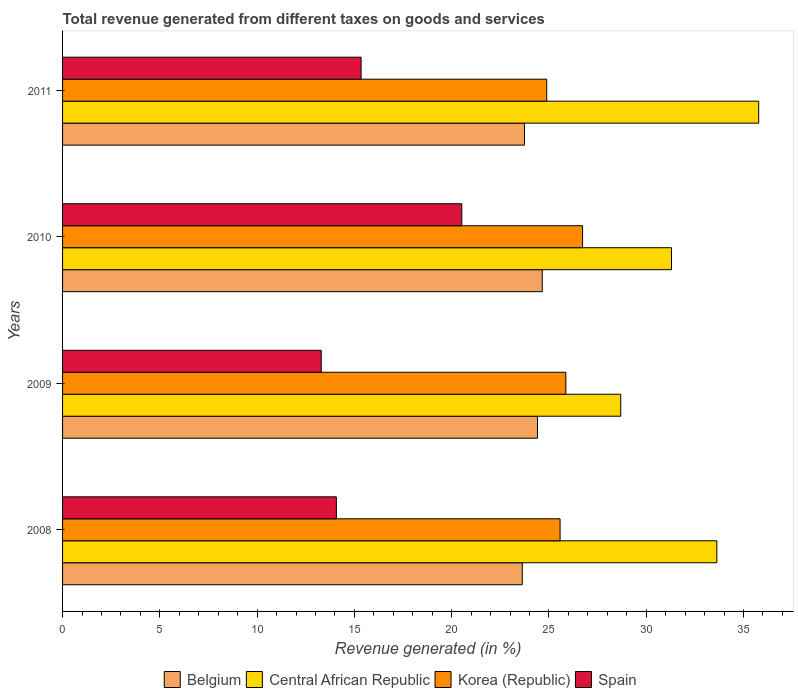How many different coloured bars are there?
Your response must be concise. 4. How many bars are there on the 3rd tick from the top?
Keep it short and to the point. 4. What is the label of the 3rd group of bars from the top?
Provide a short and direct response. 2009. What is the total revenue generated in Spain in 2009?
Offer a very short reply. 13.3. Across all years, what is the maximum total revenue generated in Belgium?
Your response must be concise. 24.65. Across all years, what is the minimum total revenue generated in Belgium?
Offer a very short reply. 23.63. In which year was the total revenue generated in Spain maximum?
Ensure brevity in your answer.  2010. In which year was the total revenue generated in Korea (Republic) minimum?
Provide a short and direct response. 2011. What is the total total revenue generated in Korea (Republic) in the graph?
Make the answer very short. 103.05. What is the difference between the total revenue generated in Central African Republic in 2008 and that in 2009?
Offer a terse response. 4.94. What is the difference between the total revenue generated in Korea (Republic) in 2010 and the total revenue generated in Central African Republic in 2011?
Keep it short and to the point. -9.05. What is the average total revenue generated in Belgium per year?
Offer a very short reply. 24.11. In the year 2009, what is the difference between the total revenue generated in Central African Republic and total revenue generated in Korea (Republic)?
Your answer should be compact. 2.82. What is the ratio of the total revenue generated in Spain in 2009 to that in 2011?
Your response must be concise. 0.87. Is the difference between the total revenue generated in Central African Republic in 2008 and 2009 greater than the difference between the total revenue generated in Korea (Republic) in 2008 and 2009?
Offer a terse response. Yes. What is the difference between the highest and the second highest total revenue generated in Spain?
Your answer should be very brief. 5.18. What is the difference between the highest and the lowest total revenue generated in Spain?
Offer a very short reply. 7.22. Is the sum of the total revenue generated in Central African Republic in 2008 and 2010 greater than the maximum total revenue generated in Belgium across all years?
Offer a terse response. Yes. What does the 3rd bar from the top in 2009 represents?
Offer a terse response. Central African Republic. What does the 2nd bar from the bottom in 2009 represents?
Give a very brief answer. Central African Republic. How many bars are there?
Your response must be concise. 16. Are all the bars in the graph horizontal?
Make the answer very short. Yes. What is the difference between two consecutive major ticks on the X-axis?
Your answer should be very brief. 5. Are the values on the major ticks of X-axis written in scientific E-notation?
Keep it short and to the point. No. Does the graph contain grids?
Offer a very short reply. No. Where does the legend appear in the graph?
Provide a short and direct response. Bottom center. How many legend labels are there?
Ensure brevity in your answer.  4. How are the legend labels stacked?
Provide a short and direct response. Horizontal. What is the title of the graph?
Your response must be concise. Total revenue generated from different taxes on goods and services. Does "Europe(all income levels)" appear as one of the legend labels in the graph?
Your answer should be very brief. No. What is the label or title of the X-axis?
Give a very brief answer. Revenue generated (in %). What is the label or title of the Y-axis?
Provide a short and direct response. Years. What is the Revenue generated (in %) in Belgium in 2008?
Provide a succinct answer. 23.63. What is the Revenue generated (in %) in Central African Republic in 2008?
Your answer should be very brief. 33.63. What is the Revenue generated (in %) in Korea (Republic) in 2008?
Offer a very short reply. 25.57. What is the Revenue generated (in %) of Spain in 2008?
Ensure brevity in your answer.  14.07. What is the Revenue generated (in %) of Belgium in 2009?
Your response must be concise. 24.41. What is the Revenue generated (in %) in Central African Republic in 2009?
Make the answer very short. 28.69. What is the Revenue generated (in %) of Korea (Republic) in 2009?
Give a very brief answer. 25.87. What is the Revenue generated (in %) in Spain in 2009?
Give a very brief answer. 13.3. What is the Revenue generated (in %) of Belgium in 2010?
Your answer should be compact. 24.65. What is the Revenue generated (in %) in Central African Republic in 2010?
Provide a short and direct response. 31.3. What is the Revenue generated (in %) in Korea (Republic) in 2010?
Your answer should be very brief. 26.73. What is the Revenue generated (in %) of Spain in 2010?
Ensure brevity in your answer.  20.52. What is the Revenue generated (in %) of Belgium in 2011?
Your answer should be compact. 23.74. What is the Revenue generated (in %) of Central African Republic in 2011?
Your response must be concise. 35.78. What is the Revenue generated (in %) in Korea (Republic) in 2011?
Provide a short and direct response. 24.88. What is the Revenue generated (in %) in Spain in 2011?
Provide a short and direct response. 15.34. Across all years, what is the maximum Revenue generated (in %) in Belgium?
Give a very brief answer. 24.65. Across all years, what is the maximum Revenue generated (in %) of Central African Republic?
Offer a very short reply. 35.78. Across all years, what is the maximum Revenue generated (in %) in Korea (Republic)?
Ensure brevity in your answer.  26.73. Across all years, what is the maximum Revenue generated (in %) in Spain?
Offer a terse response. 20.52. Across all years, what is the minimum Revenue generated (in %) in Belgium?
Your answer should be very brief. 23.63. Across all years, what is the minimum Revenue generated (in %) of Central African Republic?
Your answer should be very brief. 28.69. Across all years, what is the minimum Revenue generated (in %) in Korea (Republic)?
Your response must be concise. 24.88. Across all years, what is the minimum Revenue generated (in %) in Spain?
Offer a very short reply. 13.3. What is the total Revenue generated (in %) of Belgium in the graph?
Your response must be concise. 96.44. What is the total Revenue generated (in %) of Central African Republic in the graph?
Keep it short and to the point. 129.39. What is the total Revenue generated (in %) in Korea (Republic) in the graph?
Provide a succinct answer. 103.05. What is the total Revenue generated (in %) in Spain in the graph?
Your answer should be compact. 63.23. What is the difference between the Revenue generated (in %) in Belgium in 2008 and that in 2009?
Provide a succinct answer. -0.78. What is the difference between the Revenue generated (in %) in Central African Republic in 2008 and that in 2009?
Give a very brief answer. 4.94. What is the difference between the Revenue generated (in %) in Korea (Republic) in 2008 and that in 2009?
Ensure brevity in your answer.  -0.3. What is the difference between the Revenue generated (in %) of Spain in 2008 and that in 2009?
Offer a very short reply. 0.78. What is the difference between the Revenue generated (in %) of Belgium in 2008 and that in 2010?
Provide a short and direct response. -1.03. What is the difference between the Revenue generated (in %) in Central African Republic in 2008 and that in 2010?
Your response must be concise. 2.33. What is the difference between the Revenue generated (in %) in Korea (Republic) in 2008 and that in 2010?
Your response must be concise. -1.16. What is the difference between the Revenue generated (in %) in Spain in 2008 and that in 2010?
Offer a very short reply. -6.45. What is the difference between the Revenue generated (in %) of Belgium in 2008 and that in 2011?
Make the answer very short. -0.11. What is the difference between the Revenue generated (in %) of Central African Republic in 2008 and that in 2011?
Your response must be concise. -2.15. What is the difference between the Revenue generated (in %) in Korea (Republic) in 2008 and that in 2011?
Your response must be concise. 0.69. What is the difference between the Revenue generated (in %) of Spain in 2008 and that in 2011?
Ensure brevity in your answer.  -1.27. What is the difference between the Revenue generated (in %) of Belgium in 2009 and that in 2010?
Provide a succinct answer. -0.24. What is the difference between the Revenue generated (in %) of Central African Republic in 2009 and that in 2010?
Your response must be concise. -2.61. What is the difference between the Revenue generated (in %) of Korea (Republic) in 2009 and that in 2010?
Your answer should be compact. -0.86. What is the difference between the Revenue generated (in %) of Spain in 2009 and that in 2010?
Offer a terse response. -7.22. What is the difference between the Revenue generated (in %) in Belgium in 2009 and that in 2011?
Give a very brief answer. 0.67. What is the difference between the Revenue generated (in %) of Central African Republic in 2009 and that in 2011?
Make the answer very short. -7.09. What is the difference between the Revenue generated (in %) in Korea (Republic) in 2009 and that in 2011?
Offer a terse response. 0.98. What is the difference between the Revenue generated (in %) of Spain in 2009 and that in 2011?
Your response must be concise. -2.05. What is the difference between the Revenue generated (in %) in Belgium in 2010 and that in 2011?
Your answer should be very brief. 0.91. What is the difference between the Revenue generated (in %) in Central African Republic in 2010 and that in 2011?
Provide a succinct answer. -4.48. What is the difference between the Revenue generated (in %) of Korea (Republic) in 2010 and that in 2011?
Your answer should be very brief. 1.84. What is the difference between the Revenue generated (in %) of Spain in 2010 and that in 2011?
Give a very brief answer. 5.17. What is the difference between the Revenue generated (in %) of Belgium in 2008 and the Revenue generated (in %) of Central African Republic in 2009?
Provide a succinct answer. -5.06. What is the difference between the Revenue generated (in %) in Belgium in 2008 and the Revenue generated (in %) in Korea (Republic) in 2009?
Provide a short and direct response. -2.24. What is the difference between the Revenue generated (in %) of Belgium in 2008 and the Revenue generated (in %) of Spain in 2009?
Ensure brevity in your answer.  10.33. What is the difference between the Revenue generated (in %) of Central African Republic in 2008 and the Revenue generated (in %) of Korea (Republic) in 2009?
Your response must be concise. 7.76. What is the difference between the Revenue generated (in %) of Central African Republic in 2008 and the Revenue generated (in %) of Spain in 2009?
Your answer should be compact. 20.33. What is the difference between the Revenue generated (in %) of Korea (Republic) in 2008 and the Revenue generated (in %) of Spain in 2009?
Offer a terse response. 12.28. What is the difference between the Revenue generated (in %) in Belgium in 2008 and the Revenue generated (in %) in Central African Republic in 2010?
Your response must be concise. -7.67. What is the difference between the Revenue generated (in %) of Belgium in 2008 and the Revenue generated (in %) of Korea (Republic) in 2010?
Provide a succinct answer. -3.1. What is the difference between the Revenue generated (in %) in Belgium in 2008 and the Revenue generated (in %) in Spain in 2010?
Offer a terse response. 3.11. What is the difference between the Revenue generated (in %) in Central African Republic in 2008 and the Revenue generated (in %) in Korea (Republic) in 2010?
Provide a short and direct response. 6.9. What is the difference between the Revenue generated (in %) of Central African Republic in 2008 and the Revenue generated (in %) of Spain in 2010?
Provide a short and direct response. 13.11. What is the difference between the Revenue generated (in %) of Korea (Republic) in 2008 and the Revenue generated (in %) of Spain in 2010?
Give a very brief answer. 5.05. What is the difference between the Revenue generated (in %) of Belgium in 2008 and the Revenue generated (in %) of Central African Republic in 2011?
Give a very brief answer. -12.15. What is the difference between the Revenue generated (in %) of Belgium in 2008 and the Revenue generated (in %) of Korea (Republic) in 2011?
Provide a succinct answer. -1.26. What is the difference between the Revenue generated (in %) in Belgium in 2008 and the Revenue generated (in %) in Spain in 2011?
Offer a very short reply. 8.29. What is the difference between the Revenue generated (in %) in Central African Republic in 2008 and the Revenue generated (in %) in Korea (Republic) in 2011?
Provide a short and direct response. 8.74. What is the difference between the Revenue generated (in %) in Central African Republic in 2008 and the Revenue generated (in %) in Spain in 2011?
Your answer should be compact. 18.29. What is the difference between the Revenue generated (in %) of Korea (Republic) in 2008 and the Revenue generated (in %) of Spain in 2011?
Make the answer very short. 10.23. What is the difference between the Revenue generated (in %) of Belgium in 2009 and the Revenue generated (in %) of Central African Republic in 2010?
Your answer should be compact. -6.89. What is the difference between the Revenue generated (in %) of Belgium in 2009 and the Revenue generated (in %) of Korea (Republic) in 2010?
Give a very brief answer. -2.32. What is the difference between the Revenue generated (in %) in Belgium in 2009 and the Revenue generated (in %) in Spain in 2010?
Make the answer very short. 3.89. What is the difference between the Revenue generated (in %) in Central African Republic in 2009 and the Revenue generated (in %) in Korea (Republic) in 2010?
Your response must be concise. 1.96. What is the difference between the Revenue generated (in %) in Central African Republic in 2009 and the Revenue generated (in %) in Spain in 2010?
Your answer should be compact. 8.17. What is the difference between the Revenue generated (in %) in Korea (Republic) in 2009 and the Revenue generated (in %) in Spain in 2010?
Your answer should be compact. 5.35. What is the difference between the Revenue generated (in %) of Belgium in 2009 and the Revenue generated (in %) of Central African Republic in 2011?
Ensure brevity in your answer.  -11.37. What is the difference between the Revenue generated (in %) in Belgium in 2009 and the Revenue generated (in %) in Korea (Republic) in 2011?
Offer a terse response. -0.47. What is the difference between the Revenue generated (in %) of Belgium in 2009 and the Revenue generated (in %) of Spain in 2011?
Make the answer very short. 9.07. What is the difference between the Revenue generated (in %) in Central African Republic in 2009 and the Revenue generated (in %) in Korea (Republic) in 2011?
Give a very brief answer. 3.8. What is the difference between the Revenue generated (in %) of Central African Republic in 2009 and the Revenue generated (in %) of Spain in 2011?
Keep it short and to the point. 13.35. What is the difference between the Revenue generated (in %) in Korea (Republic) in 2009 and the Revenue generated (in %) in Spain in 2011?
Ensure brevity in your answer.  10.52. What is the difference between the Revenue generated (in %) of Belgium in 2010 and the Revenue generated (in %) of Central African Republic in 2011?
Keep it short and to the point. -11.12. What is the difference between the Revenue generated (in %) in Belgium in 2010 and the Revenue generated (in %) in Korea (Republic) in 2011?
Your response must be concise. -0.23. What is the difference between the Revenue generated (in %) of Belgium in 2010 and the Revenue generated (in %) of Spain in 2011?
Offer a terse response. 9.31. What is the difference between the Revenue generated (in %) of Central African Republic in 2010 and the Revenue generated (in %) of Korea (Republic) in 2011?
Ensure brevity in your answer.  6.41. What is the difference between the Revenue generated (in %) of Central African Republic in 2010 and the Revenue generated (in %) of Spain in 2011?
Make the answer very short. 15.95. What is the difference between the Revenue generated (in %) of Korea (Republic) in 2010 and the Revenue generated (in %) of Spain in 2011?
Offer a terse response. 11.38. What is the average Revenue generated (in %) in Belgium per year?
Make the answer very short. 24.11. What is the average Revenue generated (in %) of Central African Republic per year?
Keep it short and to the point. 32.35. What is the average Revenue generated (in %) of Korea (Republic) per year?
Offer a terse response. 25.76. What is the average Revenue generated (in %) of Spain per year?
Your answer should be compact. 15.81. In the year 2008, what is the difference between the Revenue generated (in %) of Belgium and Revenue generated (in %) of Central African Republic?
Provide a short and direct response. -10. In the year 2008, what is the difference between the Revenue generated (in %) in Belgium and Revenue generated (in %) in Korea (Republic)?
Your answer should be very brief. -1.94. In the year 2008, what is the difference between the Revenue generated (in %) of Belgium and Revenue generated (in %) of Spain?
Provide a short and direct response. 9.56. In the year 2008, what is the difference between the Revenue generated (in %) of Central African Republic and Revenue generated (in %) of Korea (Republic)?
Keep it short and to the point. 8.06. In the year 2008, what is the difference between the Revenue generated (in %) in Central African Republic and Revenue generated (in %) in Spain?
Your answer should be very brief. 19.56. In the year 2008, what is the difference between the Revenue generated (in %) of Korea (Republic) and Revenue generated (in %) of Spain?
Make the answer very short. 11.5. In the year 2009, what is the difference between the Revenue generated (in %) in Belgium and Revenue generated (in %) in Central African Republic?
Offer a very short reply. -4.28. In the year 2009, what is the difference between the Revenue generated (in %) in Belgium and Revenue generated (in %) in Korea (Republic)?
Provide a succinct answer. -1.46. In the year 2009, what is the difference between the Revenue generated (in %) of Belgium and Revenue generated (in %) of Spain?
Provide a short and direct response. 11.12. In the year 2009, what is the difference between the Revenue generated (in %) in Central African Republic and Revenue generated (in %) in Korea (Republic)?
Ensure brevity in your answer.  2.82. In the year 2009, what is the difference between the Revenue generated (in %) in Central African Republic and Revenue generated (in %) in Spain?
Offer a very short reply. 15.39. In the year 2009, what is the difference between the Revenue generated (in %) of Korea (Republic) and Revenue generated (in %) of Spain?
Offer a terse response. 12.57. In the year 2010, what is the difference between the Revenue generated (in %) in Belgium and Revenue generated (in %) in Central African Republic?
Provide a succinct answer. -6.64. In the year 2010, what is the difference between the Revenue generated (in %) in Belgium and Revenue generated (in %) in Korea (Republic)?
Offer a terse response. -2.07. In the year 2010, what is the difference between the Revenue generated (in %) of Belgium and Revenue generated (in %) of Spain?
Provide a succinct answer. 4.14. In the year 2010, what is the difference between the Revenue generated (in %) in Central African Republic and Revenue generated (in %) in Korea (Republic)?
Your response must be concise. 4.57. In the year 2010, what is the difference between the Revenue generated (in %) of Central African Republic and Revenue generated (in %) of Spain?
Offer a very short reply. 10.78. In the year 2010, what is the difference between the Revenue generated (in %) in Korea (Republic) and Revenue generated (in %) in Spain?
Provide a short and direct response. 6.21. In the year 2011, what is the difference between the Revenue generated (in %) of Belgium and Revenue generated (in %) of Central African Republic?
Provide a short and direct response. -12.04. In the year 2011, what is the difference between the Revenue generated (in %) in Belgium and Revenue generated (in %) in Korea (Republic)?
Offer a terse response. -1.14. In the year 2011, what is the difference between the Revenue generated (in %) in Belgium and Revenue generated (in %) in Spain?
Keep it short and to the point. 8.4. In the year 2011, what is the difference between the Revenue generated (in %) of Central African Republic and Revenue generated (in %) of Korea (Republic)?
Give a very brief answer. 10.89. In the year 2011, what is the difference between the Revenue generated (in %) in Central African Republic and Revenue generated (in %) in Spain?
Ensure brevity in your answer.  20.44. In the year 2011, what is the difference between the Revenue generated (in %) of Korea (Republic) and Revenue generated (in %) of Spain?
Ensure brevity in your answer.  9.54. What is the ratio of the Revenue generated (in %) in Central African Republic in 2008 to that in 2009?
Make the answer very short. 1.17. What is the ratio of the Revenue generated (in %) in Korea (Republic) in 2008 to that in 2009?
Keep it short and to the point. 0.99. What is the ratio of the Revenue generated (in %) of Spain in 2008 to that in 2009?
Provide a short and direct response. 1.06. What is the ratio of the Revenue generated (in %) of Belgium in 2008 to that in 2010?
Your answer should be very brief. 0.96. What is the ratio of the Revenue generated (in %) in Central African Republic in 2008 to that in 2010?
Offer a terse response. 1.07. What is the ratio of the Revenue generated (in %) in Korea (Republic) in 2008 to that in 2010?
Your answer should be compact. 0.96. What is the ratio of the Revenue generated (in %) in Spain in 2008 to that in 2010?
Ensure brevity in your answer.  0.69. What is the ratio of the Revenue generated (in %) in Belgium in 2008 to that in 2011?
Provide a short and direct response. 1. What is the ratio of the Revenue generated (in %) in Central African Republic in 2008 to that in 2011?
Your answer should be very brief. 0.94. What is the ratio of the Revenue generated (in %) in Korea (Republic) in 2008 to that in 2011?
Offer a terse response. 1.03. What is the ratio of the Revenue generated (in %) of Spain in 2008 to that in 2011?
Provide a short and direct response. 0.92. What is the ratio of the Revenue generated (in %) of Central African Republic in 2009 to that in 2010?
Your response must be concise. 0.92. What is the ratio of the Revenue generated (in %) in Korea (Republic) in 2009 to that in 2010?
Ensure brevity in your answer.  0.97. What is the ratio of the Revenue generated (in %) in Spain in 2009 to that in 2010?
Provide a succinct answer. 0.65. What is the ratio of the Revenue generated (in %) of Belgium in 2009 to that in 2011?
Provide a succinct answer. 1.03. What is the ratio of the Revenue generated (in %) of Central African Republic in 2009 to that in 2011?
Your answer should be compact. 0.8. What is the ratio of the Revenue generated (in %) in Korea (Republic) in 2009 to that in 2011?
Make the answer very short. 1.04. What is the ratio of the Revenue generated (in %) of Spain in 2009 to that in 2011?
Give a very brief answer. 0.87. What is the ratio of the Revenue generated (in %) of Central African Republic in 2010 to that in 2011?
Your response must be concise. 0.87. What is the ratio of the Revenue generated (in %) of Korea (Republic) in 2010 to that in 2011?
Keep it short and to the point. 1.07. What is the ratio of the Revenue generated (in %) in Spain in 2010 to that in 2011?
Keep it short and to the point. 1.34. What is the difference between the highest and the second highest Revenue generated (in %) of Belgium?
Your response must be concise. 0.24. What is the difference between the highest and the second highest Revenue generated (in %) in Central African Republic?
Your response must be concise. 2.15. What is the difference between the highest and the second highest Revenue generated (in %) of Korea (Republic)?
Keep it short and to the point. 0.86. What is the difference between the highest and the second highest Revenue generated (in %) in Spain?
Provide a short and direct response. 5.17. What is the difference between the highest and the lowest Revenue generated (in %) of Belgium?
Provide a succinct answer. 1.03. What is the difference between the highest and the lowest Revenue generated (in %) of Central African Republic?
Provide a succinct answer. 7.09. What is the difference between the highest and the lowest Revenue generated (in %) of Korea (Republic)?
Give a very brief answer. 1.84. What is the difference between the highest and the lowest Revenue generated (in %) of Spain?
Provide a short and direct response. 7.22. 